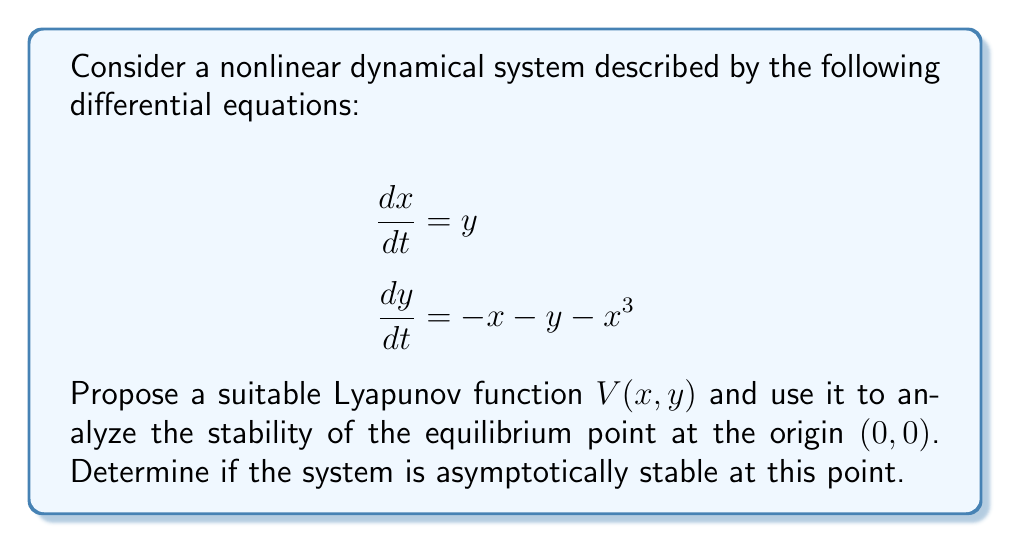Help me with this question. 1) First, let's propose a Lyapunov function. A suitable choice for this system is:

   $$V(x,y) = \frac{1}{2}(x^2 + y^2) + \frac{1}{4}x^4$$

2) To analyze stability, we need to check three conditions:
   a) $V(0,0) = 0$
   b) $V(x,y) > 0$ for all $(x,y) \neq (0,0)$
   c) $\dot{V}(x,y) < 0$ for all $(x,y) \neq (0,0)$

3) Let's check condition (a):
   $V(0,0) = \frac{1}{2}(0^2 + 0^2) + \frac{1}{4}0^4 = 0$
   This condition is satisfied.

4) For condition (b):
   $V(x,y) = \frac{1}{2}(x^2 + y^2) + \frac{1}{4}x^4 > 0$ for all $(x,y) \neq (0,0)$
   This condition is also satisfied.

5) Now, let's check condition (c) by calculating $\dot{V}(x,y)$:

   $$\begin{align}
   \dot{V}(x,y) &= \frac{\partial V}{\partial x}\frac{dx}{dt} + \frac{\partial V}{\partial y}\frac{dy}{dt} \\
   &= (x + x^3)y + y(-x - y - x^3) \\
   &= xy + x^3y - xy - y^2 - x^3y \\
   &= -y^2
   \end{align}$$

6) We can see that $\dot{V}(x,y) = -y^2 \leq 0$ for all $(x,y)$, and $\dot{V}(x,y) = 0$ only when $y = 0$ (which includes the origin).

7) To prove asymptotic stability, we need to show that the only solution that can stay identically in the set $\{\dot{V}(x,y) = 0\} = \{(x,0) : x \in \mathbb{R}\}$ is the trivial solution $(x,y) = (0,0)$.

8) If $y = 0$ and $\frac{dy}{dt} = 0$, then from the second equation of the system:
   $$0 = -x - 0 - x^3 \implies x(1 + x^2) = 0 \implies x = 0$$

9) Therefore, the only solution that can stay at $y = 0$ is $(0,0)$, which means the system is asymptotically stable at the origin.
Answer: The system is asymptotically stable at $(0,0)$. 